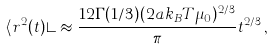<formula> <loc_0><loc_0><loc_500><loc_500>\langle r ^ { 2 } ( t ) \rangle \approx \frac { 1 2 \Gamma ( 1 / 3 ) ( 2 a k _ { B } T \mu _ { 0 } ) ^ { 2 / 3 } } { \pi } t ^ { 2 / 3 } \, ,</formula> 